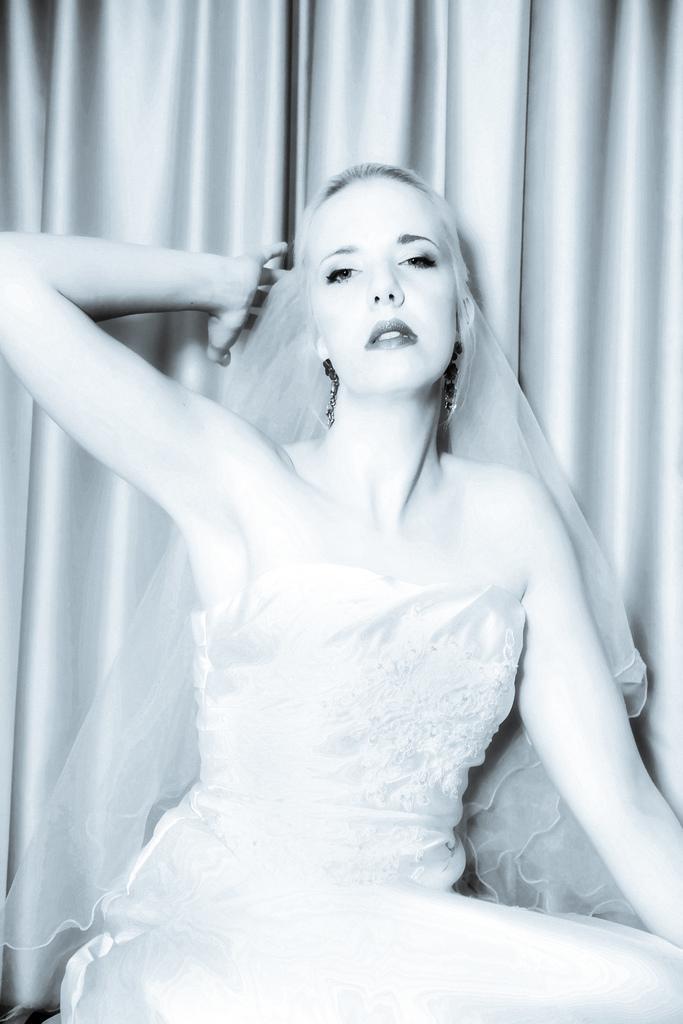Describe this image in one or two sentences. In this image we can see a lady. There is a curtain behind a lady. 